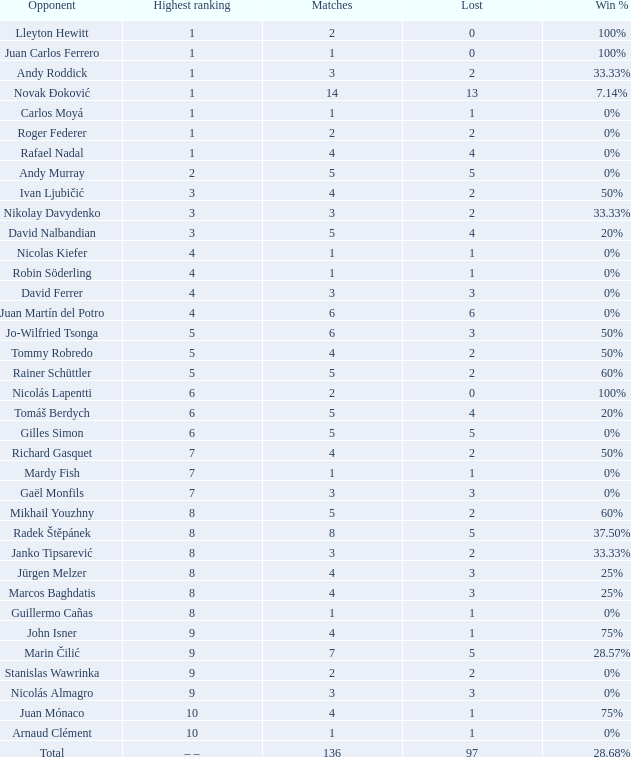What is the total number of Lost for the Highest Ranking of – –? 1.0. 